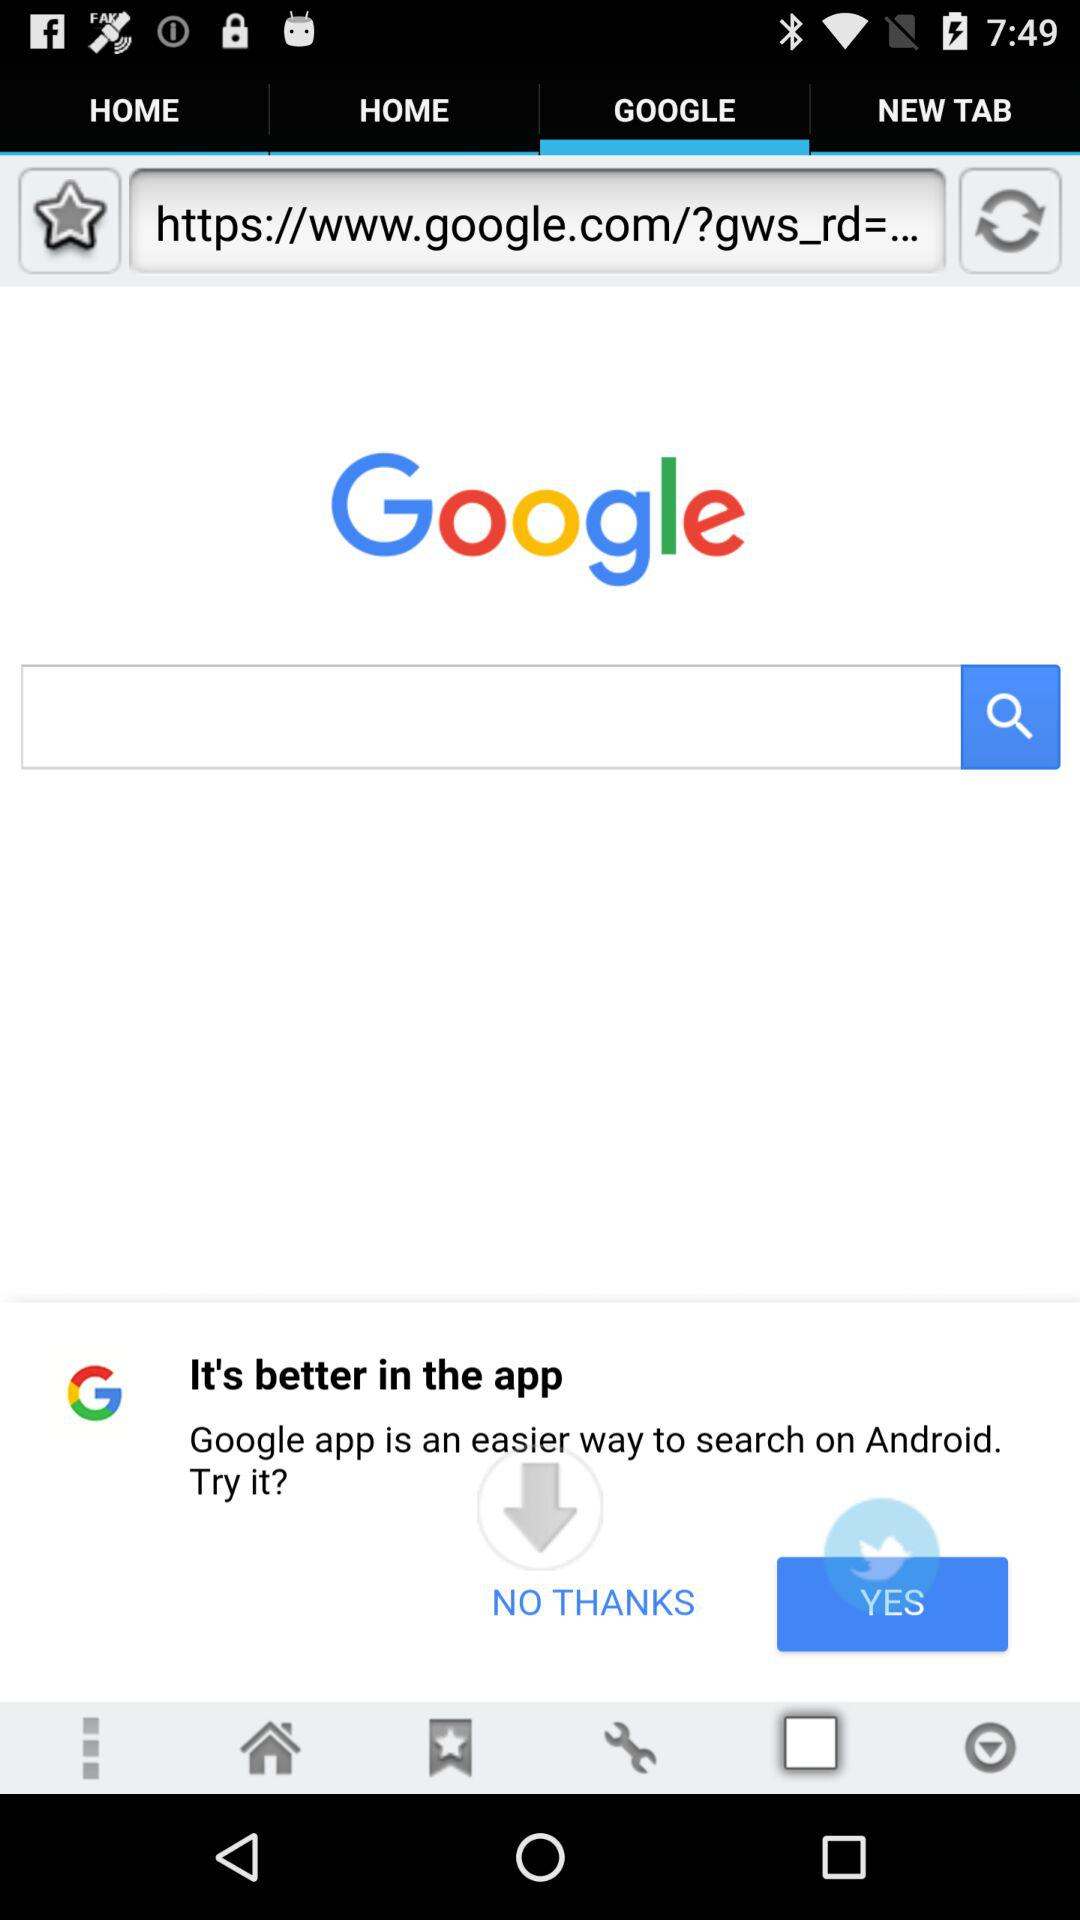What is the name of the application?
When the provided information is insufficient, respond with <no answer>. <no answer> 